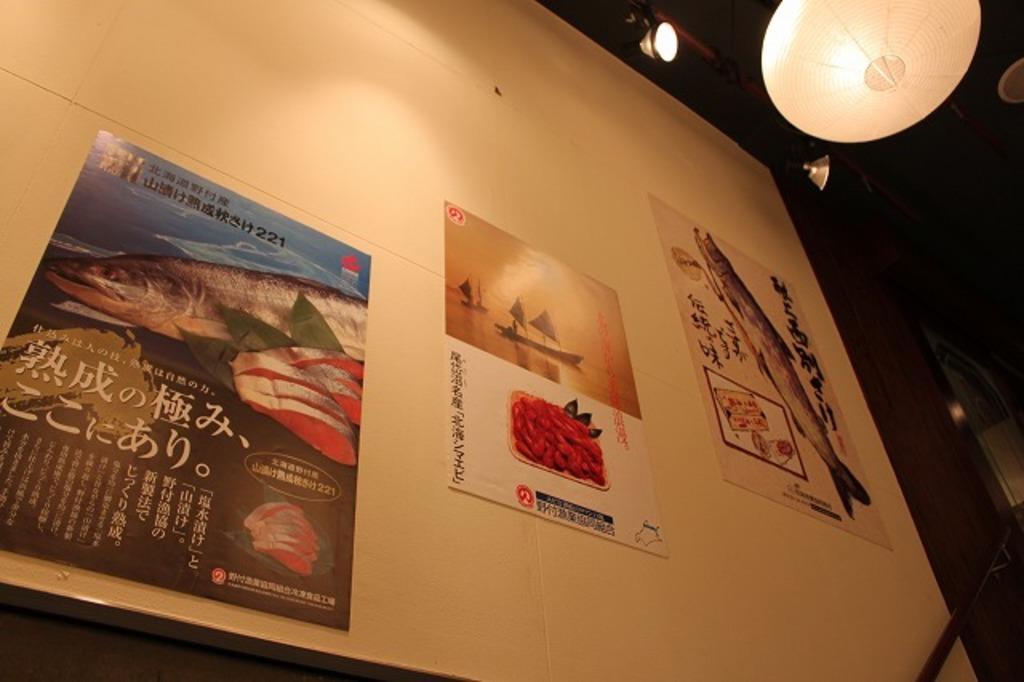Could you give a brief overview of what you see in this image? In this image we can see a white board, there are pictures on it, at the top there are lights. 